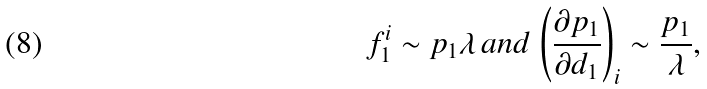<formula> <loc_0><loc_0><loc_500><loc_500>f ^ { i } _ { 1 } \sim p _ { 1 } \lambda \, a n d \, \left ( \frac { \partial p _ { 1 } } { \partial d _ { 1 } } \right ) _ { i } \sim \frac { p _ { 1 } } { \lambda } ,</formula> 